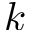<formula> <loc_0><loc_0><loc_500><loc_500>k</formula> 